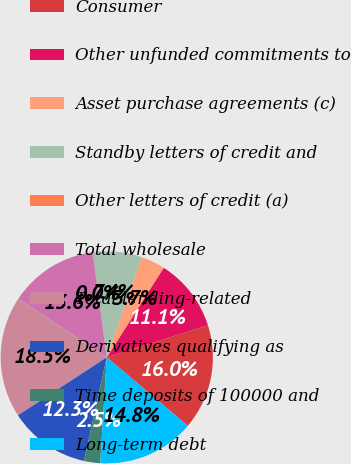<chart> <loc_0><loc_0><loc_500><loc_500><pie_chart><fcel>Consumer<fcel>Other unfunded commitments to<fcel>Asset purchase agreements (c)<fcel>Standby letters of credit and<fcel>Other letters of credit (a)<fcel>Total wholesale<fcel>Total lending-related<fcel>Derivatives qualifying as<fcel>Time deposits of 100000 and<fcel>Long-term debt<nl><fcel>16.05%<fcel>11.11%<fcel>3.71%<fcel>7.41%<fcel>0.01%<fcel>13.58%<fcel>18.51%<fcel>12.34%<fcel>2.47%<fcel>14.81%<nl></chart> 